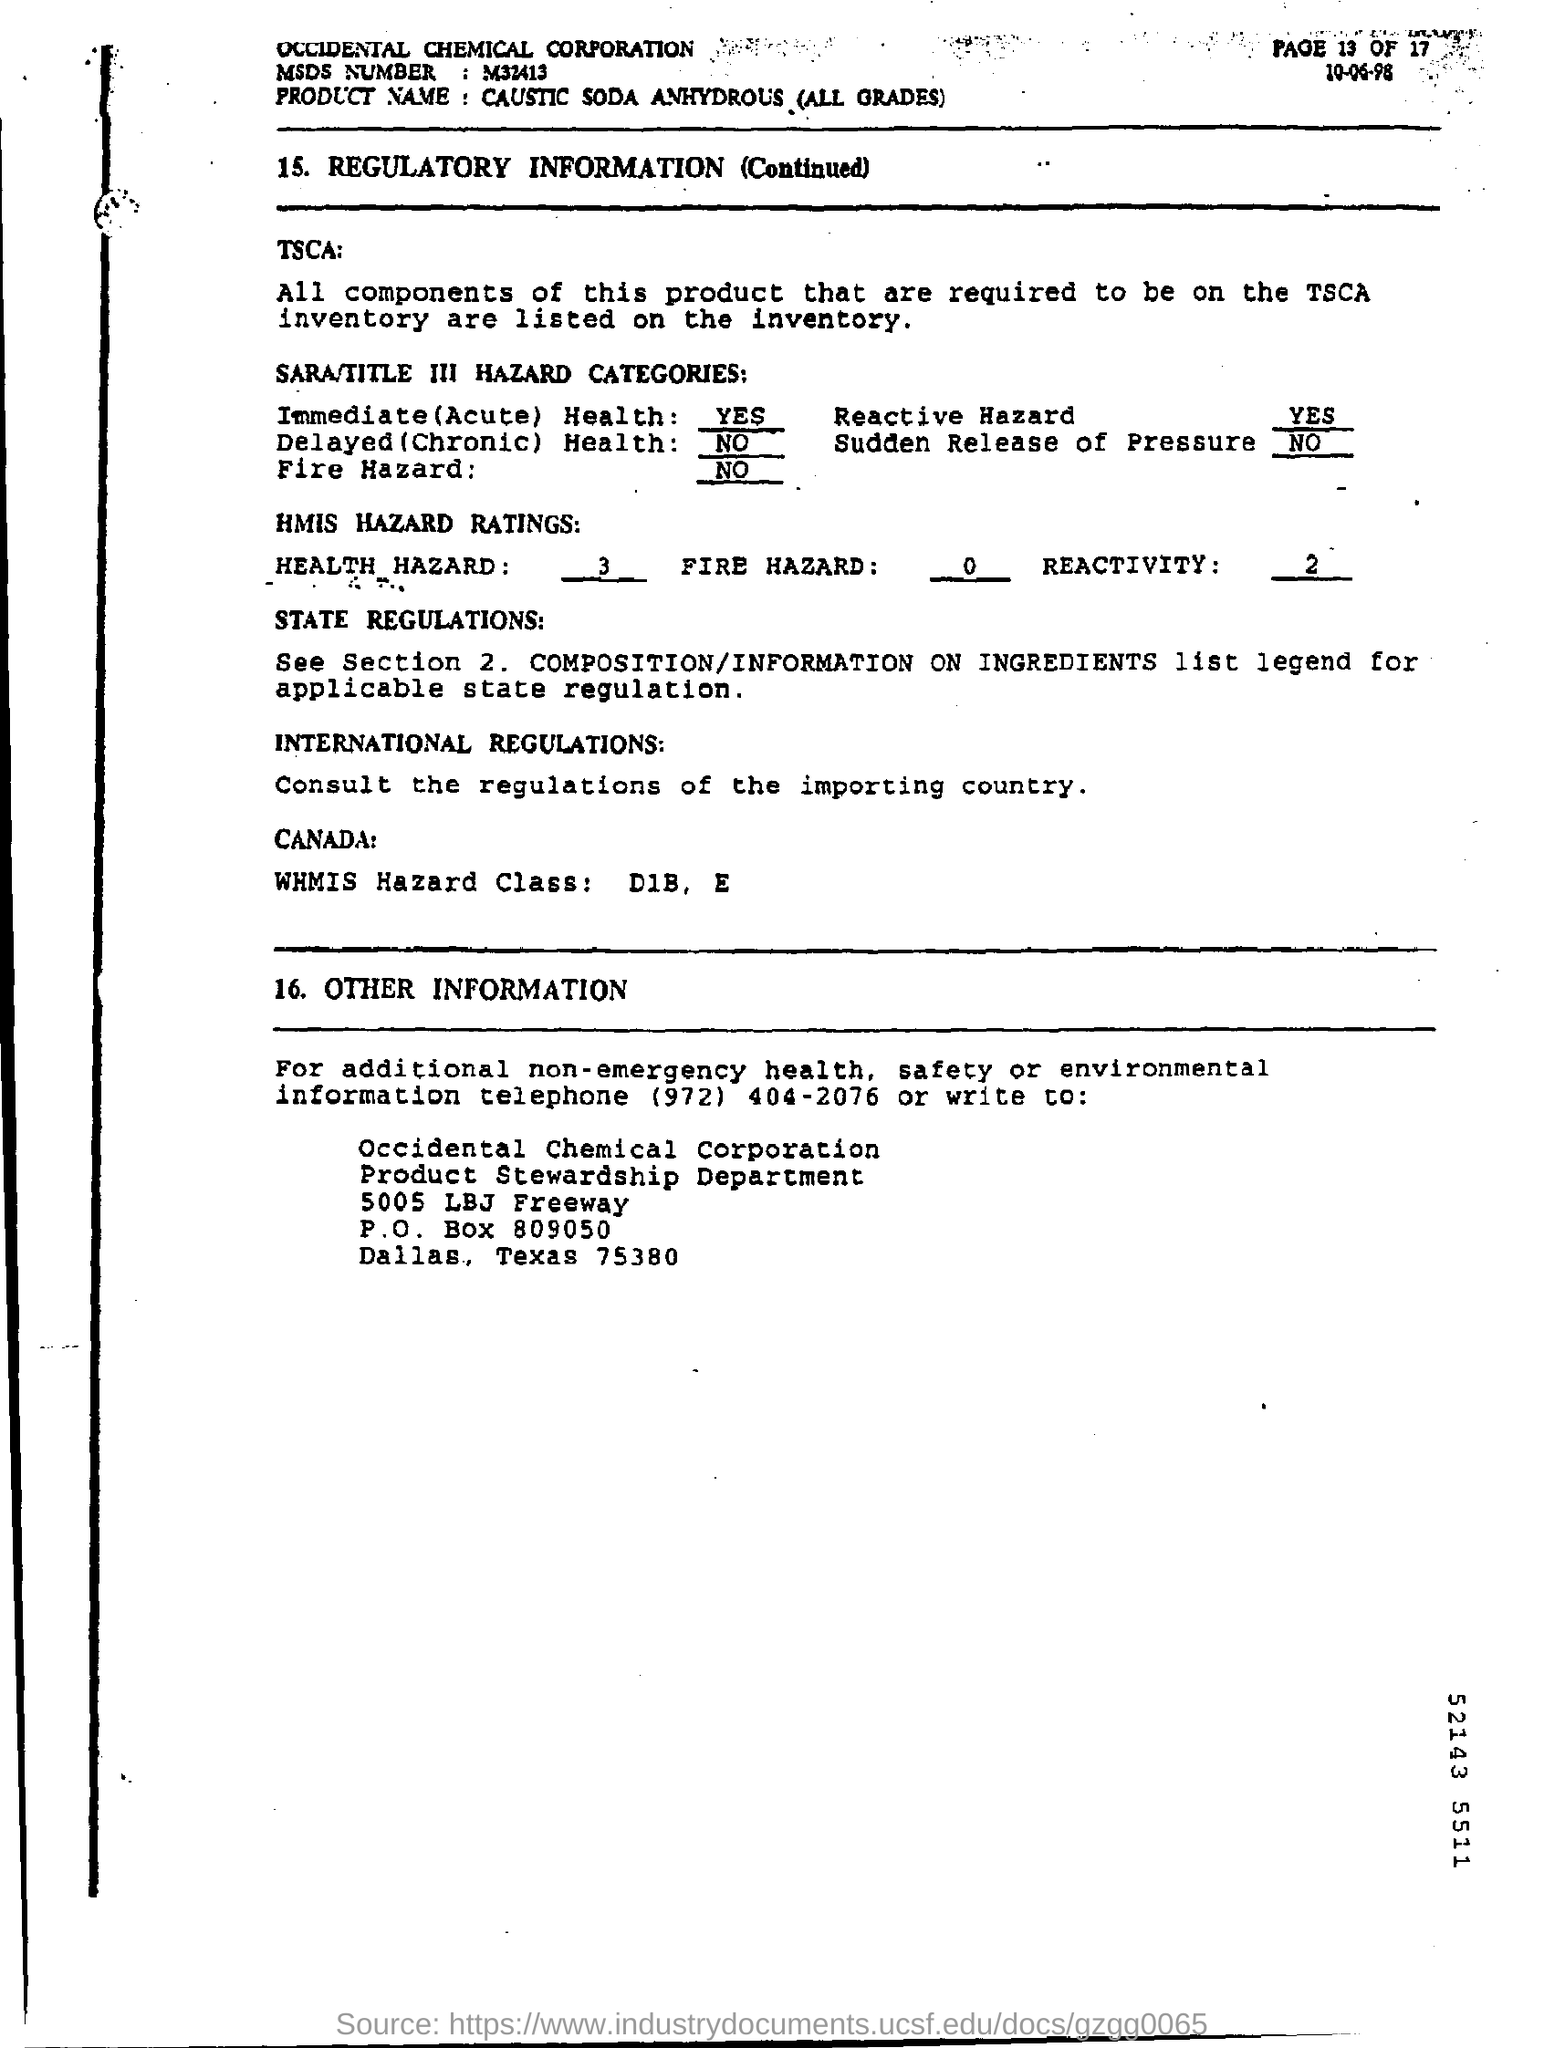What is the MSDS Number ?
Offer a terse response. M32413. What is the Product Name ?
Your answer should be very brief. CAUSTIC SODA ANHYDROUS (ALL GRADES). What is the date mentioned in the top of the document ?
Keep it short and to the point. 10-06-98. What is written in the Immediate Health Field ?
Give a very brief answer. YES. What is the Company Name ?
Provide a short and direct response. Occidental chemical corporation. What is the P.O Box Number ?
Ensure brevity in your answer.  809050. What is the Rating of Health HAZARD ?
Offer a very short reply. 3. What is written in the WHMIS Hazard Class Field ?
Offer a very short reply. D1B, E. 